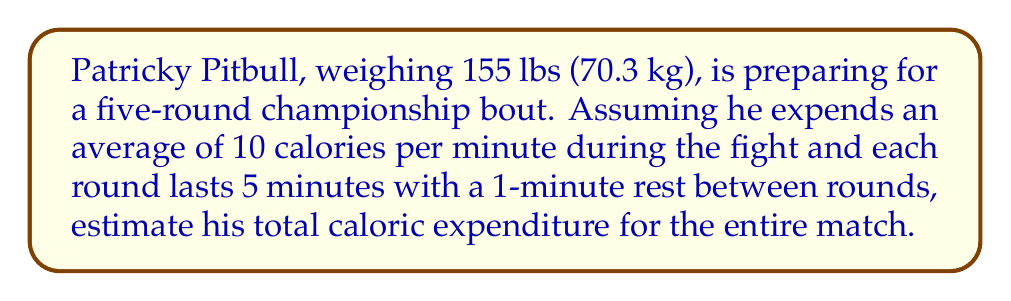What is the answer to this math problem? To solve this problem, we need to follow these steps:

1. Calculate the total fighting time:
   $$ \text{Fighting time} = 5 \text{ rounds} \times 5 \text{ minutes} = 25 \text{ minutes} $$

2. Calculate the total rest time:
   $$ \text{Rest time} = 4 \text{ breaks} \times 1 \text{ minute} = 4 \text{ minutes} $$

3. Calculate the total match duration:
   $$ \text{Total time} = \text{Fighting time} + \text{Rest time} = 25 + 4 = 29 \text{ minutes} $$

4. Calculate the caloric expenditure during fighting:
   $$ \text{Fighting calories} = 25 \text{ minutes} \times 10 \text{ calories/minute} = 250 \text{ calories} $$

5. Estimate the caloric expenditure during rest periods (assume 50% of fighting rate):
   $$ \text{Rest calories} = 4 \text{ minutes} \times (10 \text{ calories/minute} \times 0.5) = 20 \text{ calories} $$

6. Sum up the total caloric expenditure:
   $$ \text{Total calories} = \text{Fighting calories} + \text{Rest calories} = 250 + 20 = 270 \text{ calories} $$
Answer: Patricky Pitbull's estimated caloric expenditure during the five-round match is 270 calories. 